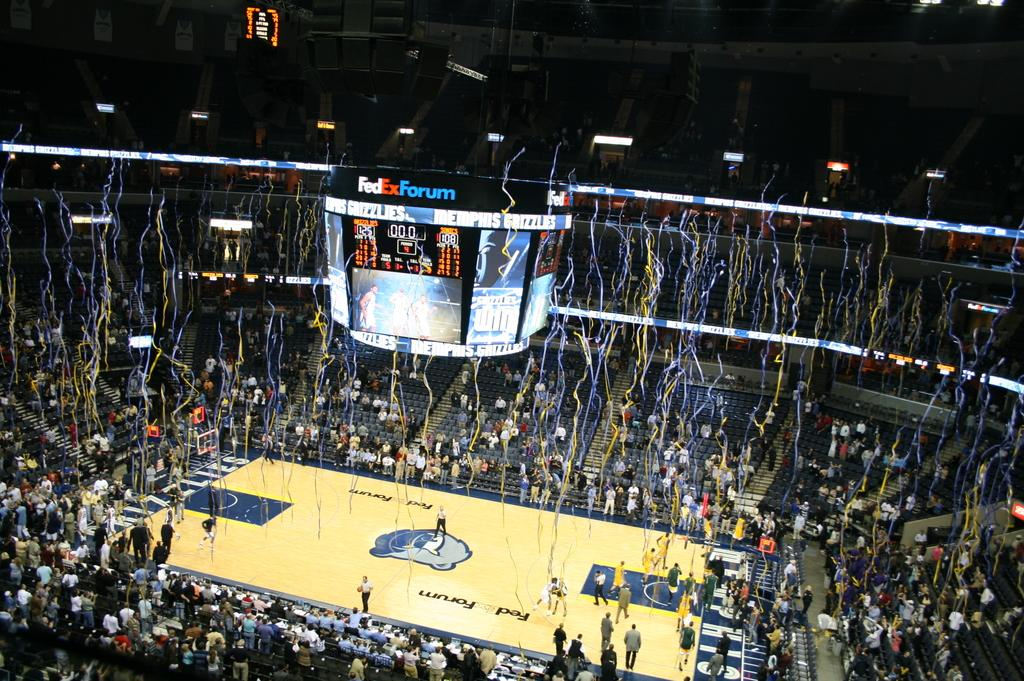<image>
Summarize the visual content of the image. Confetti falls from the rafters at FedEx Forum after a Grizzlies win 